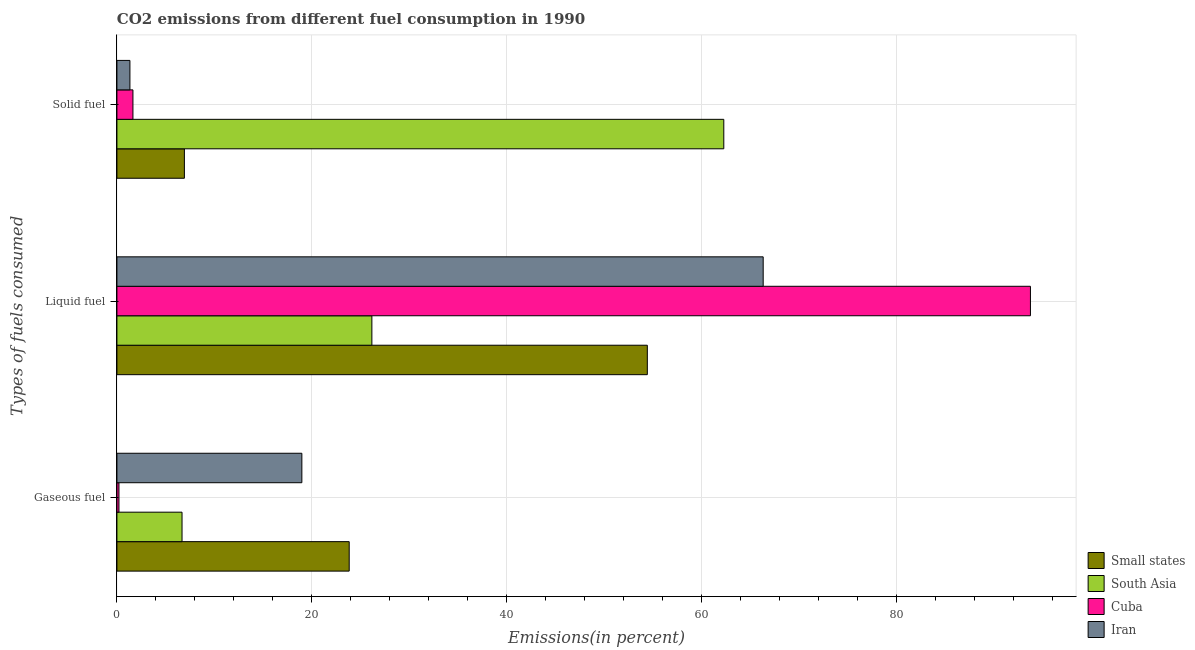How many different coloured bars are there?
Provide a succinct answer. 4. Are the number of bars on each tick of the Y-axis equal?
Offer a terse response. Yes. How many bars are there on the 1st tick from the bottom?
Provide a succinct answer. 4. What is the label of the 3rd group of bars from the top?
Your answer should be very brief. Gaseous fuel. What is the percentage of solid fuel emission in South Asia?
Keep it short and to the point. 62.24. Across all countries, what is the maximum percentage of gaseous fuel emission?
Keep it short and to the point. 23.82. Across all countries, what is the minimum percentage of gaseous fuel emission?
Make the answer very short. 0.21. In which country was the percentage of liquid fuel emission maximum?
Your answer should be compact. Cuba. In which country was the percentage of gaseous fuel emission minimum?
Provide a succinct answer. Cuba. What is the total percentage of solid fuel emission in the graph?
Offer a very short reply. 72.14. What is the difference between the percentage of solid fuel emission in Cuba and that in Iran?
Offer a very short reply. 0.31. What is the difference between the percentage of solid fuel emission in South Asia and the percentage of liquid fuel emission in Cuba?
Your answer should be compact. -31.45. What is the average percentage of liquid fuel emission per country?
Give a very brief answer. 60.13. What is the difference between the percentage of liquid fuel emission and percentage of gaseous fuel emission in Cuba?
Offer a very short reply. 93.49. What is the ratio of the percentage of liquid fuel emission in Small states to that in Iran?
Give a very brief answer. 0.82. Is the difference between the percentage of solid fuel emission in Iran and Small states greater than the difference between the percentage of gaseous fuel emission in Iran and Small states?
Make the answer very short. No. What is the difference between the highest and the second highest percentage of solid fuel emission?
Ensure brevity in your answer.  55.32. What is the difference between the highest and the lowest percentage of solid fuel emission?
Provide a short and direct response. 60.91. In how many countries, is the percentage of gaseous fuel emission greater than the average percentage of gaseous fuel emission taken over all countries?
Provide a short and direct response. 2. Is the sum of the percentage of solid fuel emission in South Asia and Cuba greater than the maximum percentage of liquid fuel emission across all countries?
Provide a short and direct response. No. What does the 1st bar from the top in Liquid fuel represents?
Make the answer very short. Iran. What does the 4th bar from the bottom in Gaseous fuel represents?
Provide a short and direct response. Iran. Is it the case that in every country, the sum of the percentage of gaseous fuel emission and percentage of liquid fuel emission is greater than the percentage of solid fuel emission?
Provide a short and direct response. No. Are all the bars in the graph horizontal?
Make the answer very short. Yes. How many countries are there in the graph?
Offer a very short reply. 4. Are the values on the major ticks of X-axis written in scientific E-notation?
Keep it short and to the point. No. How are the legend labels stacked?
Make the answer very short. Vertical. What is the title of the graph?
Provide a short and direct response. CO2 emissions from different fuel consumption in 1990. Does "Italy" appear as one of the legend labels in the graph?
Your answer should be compact. No. What is the label or title of the X-axis?
Provide a succinct answer. Emissions(in percent). What is the label or title of the Y-axis?
Your response must be concise. Types of fuels consumed. What is the Emissions(in percent) of Small states in Gaseous fuel?
Provide a short and direct response. 23.82. What is the Emissions(in percent) in South Asia in Gaseous fuel?
Your answer should be compact. 6.68. What is the Emissions(in percent) in Cuba in Gaseous fuel?
Your response must be concise. 0.21. What is the Emissions(in percent) in Iran in Gaseous fuel?
Your answer should be very brief. 18.97. What is the Emissions(in percent) of Small states in Liquid fuel?
Offer a terse response. 54.4. What is the Emissions(in percent) in South Asia in Liquid fuel?
Provide a short and direct response. 26.15. What is the Emissions(in percent) in Cuba in Liquid fuel?
Provide a short and direct response. 93.69. What is the Emissions(in percent) in Iran in Liquid fuel?
Keep it short and to the point. 66.28. What is the Emissions(in percent) in Small states in Solid fuel?
Make the answer very short. 6.92. What is the Emissions(in percent) of South Asia in Solid fuel?
Keep it short and to the point. 62.24. What is the Emissions(in percent) of Cuba in Solid fuel?
Provide a succinct answer. 1.64. What is the Emissions(in percent) of Iran in Solid fuel?
Give a very brief answer. 1.33. Across all Types of fuels consumed, what is the maximum Emissions(in percent) of Small states?
Give a very brief answer. 54.4. Across all Types of fuels consumed, what is the maximum Emissions(in percent) in South Asia?
Offer a very short reply. 62.24. Across all Types of fuels consumed, what is the maximum Emissions(in percent) of Cuba?
Provide a succinct answer. 93.69. Across all Types of fuels consumed, what is the maximum Emissions(in percent) of Iran?
Your answer should be very brief. 66.28. Across all Types of fuels consumed, what is the minimum Emissions(in percent) of Small states?
Your answer should be compact. 6.92. Across all Types of fuels consumed, what is the minimum Emissions(in percent) in South Asia?
Offer a very short reply. 6.68. Across all Types of fuels consumed, what is the minimum Emissions(in percent) in Cuba?
Your response must be concise. 0.21. Across all Types of fuels consumed, what is the minimum Emissions(in percent) of Iran?
Your answer should be very brief. 1.33. What is the total Emissions(in percent) in Small states in the graph?
Offer a very short reply. 85.14. What is the total Emissions(in percent) of South Asia in the graph?
Your answer should be very brief. 95.07. What is the total Emissions(in percent) of Cuba in the graph?
Your answer should be compact. 95.54. What is the total Emissions(in percent) in Iran in the graph?
Give a very brief answer. 86.58. What is the difference between the Emissions(in percent) in Small states in Gaseous fuel and that in Liquid fuel?
Your answer should be very brief. -30.58. What is the difference between the Emissions(in percent) of South Asia in Gaseous fuel and that in Liquid fuel?
Keep it short and to the point. -19.47. What is the difference between the Emissions(in percent) in Cuba in Gaseous fuel and that in Liquid fuel?
Keep it short and to the point. -93.49. What is the difference between the Emissions(in percent) of Iran in Gaseous fuel and that in Liquid fuel?
Make the answer very short. -47.32. What is the difference between the Emissions(in percent) in Small states in Gaseous fuel and that in Solid fuel?
Give a very brief answer. 16.9. What is the difference between the Emissions(in percent) in South Asia in Gaseous fuel and that in Solid fuel?
Give a very brief answer. -55.56. What is the difference between the Emissions(in percent) of Cuba in Gaseous fuel and that in Solid fuel?
Ensure brevity in your answer.  -1.43. What is the difference between the Emissions(in percent) of Iran in Gaseous fuel and that in Solid fuel?
Keep it short and to the point. 17.63. What is the difference between the Emissions(in percent) in Small states in Liquid fuel and that in Solid fuel?
Make the answer very short. 47.48. What is the difference between the Emissions(in percent) of South Asia in Liquid fuel and that in Solid fuel?
Offer a terse response. -36.09. What is the difference between the Emissions(in percent) in Cuba in Liquid fuel and that in Solid fuel?
Give a very brief answer. 92.05. What is the difference between the Emissions(in percent) of Iran in Liquid fuel and that in Solid fuel?
Your answer should be compact. 64.95. What is the difference between the Emissions(in percent) of Small states in Gaseous fuel and the Emissions(in percent) of South Asia in Liquid fuel?
Your response must be concise. -2.33. What is the difference between the Emissions(in percent) in Small states in Gaseous fuel and the Emissions(in percent) in Cuba in Liquid fuel?
Make the answer very short. -69.87. What is the difference between the Emissions(in percent) of Small states in Gaseous fuel and the Emissions(in percent) of Iran in Liquid fuel?
Keep it short and to the point. -42.46. What is the difference between the Emissions(in percent) of South Asia in Gaseous fuel and the Emissions(in percent) of Cuba in Liquid fuel?
Keep it short and to the point. -87.02. What is the difference between the Emissions(in percent) of South Asia in Gaseous fuel and the Emissions(in percent) of Iran in Liquid fuel?
Keep it short and to the point. -59.6. What is the difference between the Emissions(in percent) of Cuba in Gaseous fuel and the Emissions(in percent) of Iran in Liquid fuel?
Your response must be concise. -66.08. What is the difference between the Emissions(in percent) in Small states in Gaseous fuel and the Emissions(in percent) in South Asia in Solid fuel?
Your answer should be very brief. -38.42. What is the difference between the Emissions(in percent) of Small states in Gaseous fuel and the Emissions(in percent) of Cuba in Solid fuel?
Offer a terse response. 22.18. What is the difference between the Emissions(in percent) in Small states in Gaseous fuel and the Emissions(in percent) in Iran in Solid fuel?
Provide a succinct answer. 22.49. What is the difference between the Emissions(in percent) in South Asia in Gaseous fuel and the Emissions(in percent) in Cuba in Solid fuel?
Your answer should be very brief. 5.04. What is the difference between the Emissions(in percent) in South Asia in Gaseous fuel and the Emissions(in percent) in Iran in Solid fuel?
Offer a very short reply. 5.34. What is the difference between the Emissions(in percent) in Cuba in Gaseous fuel and the Emissions(in percent) in Iran in Solid fuel?
Your answer should be compact. -1.13. What is the difference between the Emissions(in percent) in Small states in Liquid fuel and the Emissions(in percent) in South Asia in Solid fuel?
Your answer should be very brief. -7.84. What is the difference between the Emissions(in percent) of Small states in Liquid fuel and the Emissions(in percent) of Cuba in Solid fuel?
Offer a terse response. 52.76. What is the difference between the Emissions(in percent) in Small states in Liquid fuel and the Emissions(in percent) in Iran in Solid fuel?
Give a very brief answer. 53.07. What is the difference between the Emissions(in percent) in South Asia in Liquid fuel and the Emissions(in percent) in Cuba in Solid fuel?
Your response must be concise. 24.51. What is the difference between the Emissions(in percent) of South Asia in Liquid fuel and the Emissions(in percent) of Iran in Solid fuel?
Provide a succinct answer. 24.82. What is the difference between the Emissions(in percent) in Cuba in Liquid fuel and the Emissions(in percent) in Iran in Solid fuel?
Provide a succinct answer. 92.36. What is the average Emissions(in percent) in Small states per Types of fuels consumed?
Your answer should be compact. 28.38. What is the average Emissions(in percent) of South Asia per Types of fuels consumed?
Provide a succinct answer. 31.69. What is the average Emissions(in percent) in Cuba per Types of fuels consumed?
Offer a terse response. 31.85. What is the average Emissions(in percent) of Iran per Types of fuels consumed?
Ensure brevity in your answer.  28.86. What is the difference between the Emissions(in percent) of Small states and Emissions(in percent) of South Asia in Gaseous fuel?
Offer a terse response. 17.15. What is the difference between the Emissions(in percent) in Small states and Emissions(in percent) in Cuba in Gaseous fuel?
Provide a succinct answer. 23.62. What is the difference between the Emissions(in percent) of Small states and Emissions(in percent) of Iran in Gaseous fuel?
Keep it short and to the point. 4.86. What is the difference between the Emissions(in percent) in South Asia and Emissions(in percent) in Cuba in Gaseous fuel?
Provide a short and direct response. 6.47. What is the difference between the Emissions(in percent) of South Asia and Emissions(in percent) of Iran in Gaseous fuel?
Offer a very short reply. -12.29. What is the difference between the Emissions(in percent) of Cuba and Emissions(in percent) of Iran in Gaseous fuel?
Give a very brief answer. -18.76. What is the difference between the Emissions(in percent) of Small states and Emissions(in percent) of South Asia in Liquid fuel?
Provide a succinct answer. 28.25. What is the difference between the Emissions(in percent) of Small states and Emissions(in percent) of Cuba in Liquid fuel?
Your response must be concise. -39.29. What is the difference between the Emissions(in percent) of Small states and Emissions(in percent) of Iran in Liquid fuel?
Provide a short and direct response. -11.88. What is the difference between the Emissions(in percent) of South Asia and Emissions(in percent) of Cuba in Liquid fuel?
Give a very brief answer. -67.54. What is the difference between the Emissions(in percent) in South Asia and Emissions(in percent) in Iran in Liquid fuel?
Your answer should be very brief. -40.13. What is the difference between the Emissions(in percent) of Cuba and Emissions(in percent) of Iran in Liquid fuel?
Your answer should be very brief. 27.41. What is the difference between the Emissions(in percent) in Small states and Emissions(in percent) in South Asia in Solid fuel?
Offer a very short reply. -55.32. What is the difference between the Emissions(in percent) in Small states and Emissions(in percent) in Cuba in Solid fuel?
Ensure brevity in your answer.  5.28. What is the difference between the Emissions(in percent) of Small states and Emissions(in percent) of Iran in Solid fuel?
Your response must be concise. 5.59. What is the difference between the Emissions(in percent) of South Asia and Emissions(in percent) of Cuba in Solid fuel?
Offer a very short reply. 60.6. What is the difference between the Emissions(in percent) in South Asia and Emissions(in percent) in Iran in Solid fuel?
Offer a terse response. 60.91. What is the difference between the Emissions(in percent) in Cuba and Emissions(in percent) in Iran in Solid fuel?
Give a very brief answer. 0.31. What is the ratio of the Emissions(in percent) in Small states in Gaseous fuel to that in Liquid fuel?
Your answer should be compact. 0.44. What is the ratio of the Emissions(in percent) in South Asia in Gaseous fuel to that in Liquid fuel?
Make the answer very short. 0.26. What is the ratio of the Emissions(in percent) in Cuba in Gaseous fuel to that in Liquid fuel?
Keep it short and to the point. 0. What is the ratio of the Emissions(in percent) in Iran in Gaseous fuel to that in Liquid fuel?
Offer a terse response. 0.29. What is the ratio of the Emissions(in percent) of Small states in Gaseous fuel to that in Solid fuel?
Offer a terse response. 3.44. What is the ratio of the Emissions(in percent) in South Asia in Gaseous fuel to that in Solid fuel?
Your response must be concise. 0.11. What is the ratio of the Emissions(in percent) in Cuba in Gaseous fuel to that in Solid fuel?
Provide a short and direct response. 0.13. What is the ratio of the Emissions(in percent) of Iran in Gaseous fuel to that in Solid fuel?
Your response must be concise. 14.22. What is the ratio of the Emissions(in percent) in Small states in Liquid fuel to that in Solid fuel?
Make the answer very short. 7.86. What is the ratio of the Emissions(in percent) of South Asia in Liquid fuel to that in Solid fuel?
Make the answer very short. 0.42. What is the ratio of the Emissions(in percent) in Cuba in Liquid fuel to that in Solid fuel?
Provide a short and direct response. 57.05. What is the ratio of the Emissions(in percent) in Iran in Liquid fuel to that in Solid fuel?
Ensure brevity in your answer.  49.69. What is the difference between the highest and the second highest Emissions(in percent) of Small states?
Your answer should be compact. 30.58. What is the difference between the highest and the second highest Emissions(in percent) in South Asia?
Your answer should be compact. 36.09. What is the difference between the highest and the second highest Emissions(in percent) in Cuba?
Provide a short and direct response. 92.05. What is the difference between the highest and the second highest Emissions(in percent) of Iran?
Give a very brief answer. 47.32. What is the difference between the highest and the lowest Emissions(in percent) of Small states?
Offer a terse response. 47.48. What is the difference between the highest and the lowest Emissions(in percent) of South Asia?
Provide a succinct answer. 55.56. What is the difference between the highest and the lowest Emissions(in percent) in Cuba?
Provide a short and direct response. 93.49. What is the difference between the highest and the lowest Emissions(in percent) in Iran?
Your answer should be compact. 64.95. 